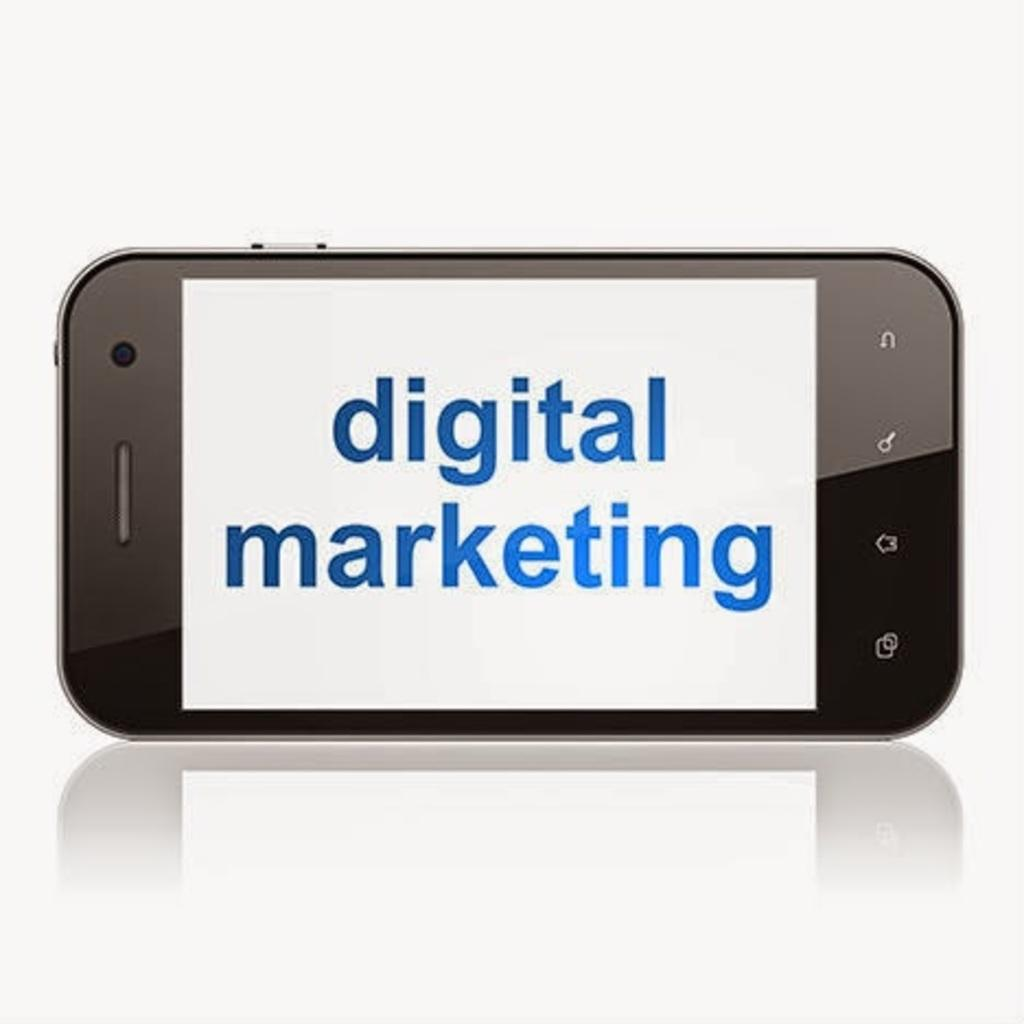What electronic device is present in the image? There is a smartphone in the image. How is the smartphone positioned on the platform? The smartphone is kept horizontally on a platform. What can be seen on the smartphone screen? There is text on the smartphone screen. Can you describe the reflection of the smartphone in the image? There is a reflection of the smartphone at the bottom of the image. What type of tax is being discussed on the smartphone screen? There is no discussion of tax on the smartphone screen; it only displays text. 